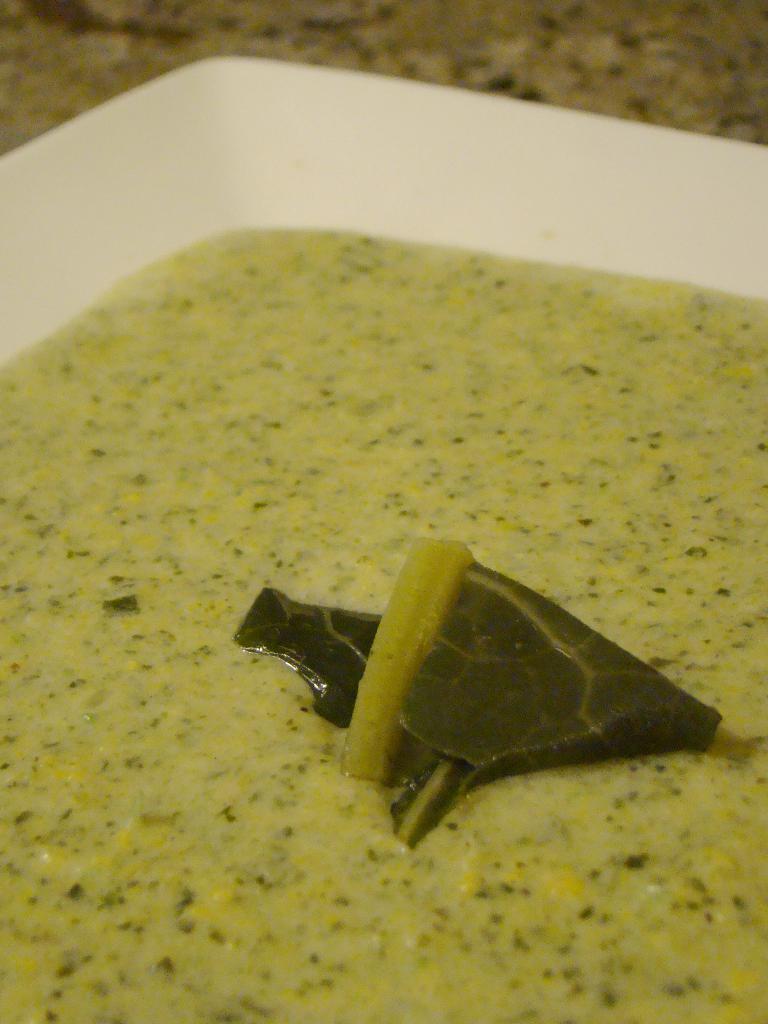Please provide a concise description of this image. In this image, we can see a plate contains some food. 